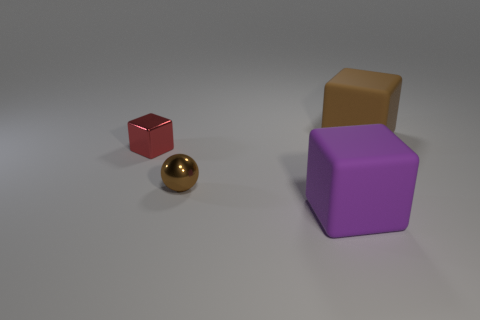There is a cube that is the same color as the metallic ball; what is it made of?
Provide a short and direct response. Rubber. Are the large block in front of the large brown cube and the tiny object behind the shiny ball made of the same material?
Make the answer very short. No. There is a block to the right of the big thing in front of the block that is to the right of the purple object; what is its size?
Keep it short and to the point. Large. There is a brown object that is the same size as the purple matte block; what is its material?
Ensure brevity in your answer.  Rubber. Are there any matte blocks that have the same size as the sphere?
Your answer should be very brief. No. Is the shape of the purple object the same as the big brown thing?
Offer a terse response. Yes. Is there a purple thing to the right of the block that is behind the block left of the tiny sphere?
Make the answer very short. No. What number of other objects are there of the same color as the small block?
Keep it short and to the point. 0. There is a brown thing that is left of the big purple rubber object; is its size the same as the rubber thing on the left side of the brown rubber thing?
Offer a terse response. No. Are there the same number of tiny cubes that are in front of the brown sphere and tiny cubes that are behind the brown cube?
Your answer should be compact. Yes. 